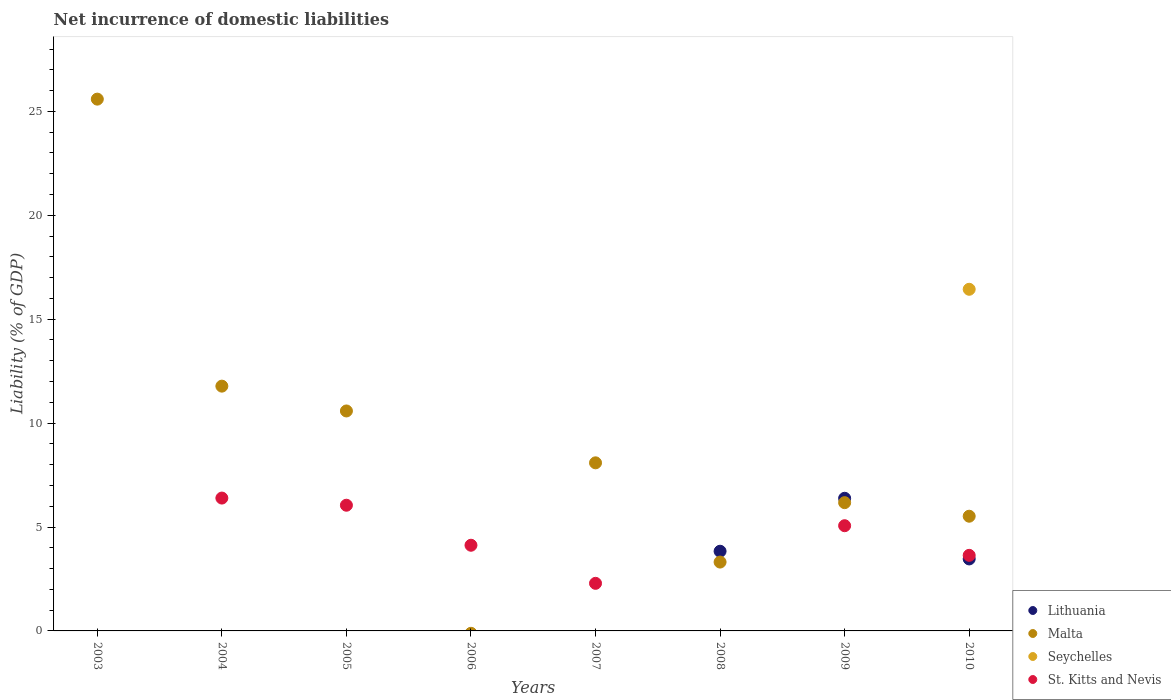What is the net incurrence of domestic liabilities in St. Kitts and Nevis in 2006?
Give a very brief answer. 4.12. Across all years, what is the maximum net incurrence of domestic liabilities in Seychelles?
Keep it short and to the point. 16.44. Across all years, what is the minimum net incurrence of domestic liabilities in Seychelles?
Offer a terse response. 0. In which year was the net incurrence of domestic liabilities in Lithuania maximum?
Your response must be concise. 2009. What is the total net incurrence of domestic liabilities in St. Kitts and Nevis in the graph?
Offer a terse response. 27.55. What is the difference between the net incurrence of domestic liabilities in St. Kitts and Nevis in 2004 and that in 2006?
Give a very brief answer. 2.27. What is the average net incurrence of domestic liabilities in St. Kitts and Nevis per year?
Offer a terse response. 3.44. In the year 2010, what is the difference between the net incurrence of domestic liabilities in Lithuania and net incurrence of domestic liabilities in St. Kitts and Nevis?
Make the answer very short. -0.17. What is the ratio of the net incurrence of domestic liabilities in Malta in 2004 to that in 2009?
Offer a very short reply. 1.91. Is the net incurrence of domestic liabilities in Malta in 2003 less than that in 2008?
Offer a terse response. No. What is the difference between the highest and the second highest net incurrence of domestic liabilities in Malta?
Give a very brief answer. 13.81. What is the difference between the highest and the lowest net incurrence of domestic liabilities in Seychelles?
Keep it short and to the point. 16.44. Is it the case that in every year, the sum of the net incurrence of domestic liabilities in St. Kitts and Nevis and net incurrence of domestic liabilities in Malta  is greater than the net incurrence of domestic liabilities in Seychelles?
Provide a short and direct response. No. Does the net incurrence of domestic liabilities in Lithuania monotonically increase over the years?
Offer a terse response. No. Is the net incurrence of domestic liabilities in Malta strictly less than the net incurrence of domestic liabilities in Lithuania over the years?
Offer a terse response. No. What is the difference between two consecutive major ticks on the Y-axis?
Ensure brevity in your answer.  5. Are the values on the major ticks of Y-axis written in scientific E-notation?
Provide a short and direct response. No. Does the graph contain any zero values?
Provide a short and direct response. Yes. Does the graph contain grids?
Ensure brevity in your answer.  No. Where does the legend appear in the graph?
Your answer should be very brief. Bottom right. How many legend labels are there?
Your answer should be compact. 4. How are the legend labels stacked?
Your answer should be very brief. Vertical. What is the title of the graph?
Keep it short and to the point. Net incurrence of domestic liabilities. Does "Costa Rica" appear as one of the legend labels in the graph?
Your answer should be very brief. No. What is the label or title of the X-axis?
Offer a very short reply. Years. What is the label or title of the Y-axis?
Provide a succinct answer. Liability (% of GDP). What is the Liability (% of GDP) in Lithuania in 2003?
Ensure brevity in your answer.  0. What is the Liability (% of GDP) of Malta in 2003?
Your response must be concise. 25.59. What is the Liability (% of GDP) of Seychelles in 2003?
Your answer should be very brief. 0. What is the Liability (% of GDP) in Malta in 2004?
Provide a short and direct response. 11.78. What is the Liability (% of GDP) of St. Kitts and Nevis in 2004?
Ensure brevity in your answer.  6.39. What is the Liability (% of GDP) in Malta in 2005?
Make the answer very short. 10.58. What is the Liability (% of GDP) in Seychelles in 2005?
Give a very brief answer. 0. What is the Liability (% of GDP) of St. Kitts and Nevis in 2005?
Your answer should be compact. 6.05. What is the Liability (% of GDP) of Seychelles in 2006?
Make the answer very short. 0. What is the Liability (% of GDP) in St. Kitts and Nevis in 2006?
Ensure brevity in your answer.  4.12. What is the Liability (% of GDP) in Malta in 2007?
Your response must be concise. 8.09. What is the Liability (% of GDP) of Seychelles in 2007?
Your answer should be very brief. 0. What is the Liability (% of GDP) of St. Kitts and Nevis in 2007?
Keep it short and to the point. 2.29. What is the Liability (% of GDP) of Lithuania in 2008?
Provide a short and direct response. 3.83. What is the Liability (% of GDP) of Malta in 2008?
Give a very brief answer. 3.31. What is the Liability (% of GDP) of Lithuania in 2009?
Your answer should be compact. 6.38. What is the Liability (% of GDP) in Malta in 2009?
Keep it short and to the point. 6.17. What is the Liability (% of GDP) of St. Kitts and Nevis in 2009?
Provide a short and direct response. 5.06. What is the Liability (% of GDP) of Lithuania in 2010?
Your answer should be very brief. 3.46. What is the Liability (% of GDP) of Malta in 2010?
Offer a very short reply. 5.52. What is the Liability (% of GDP) in Seychelles in 2010?
Provide a succinct answer. 16.44. What is the Liability (% of GDP) of St. Kitts and Nevis in 2010?
Your answer should be compact. 3.64. Across all years, what is the maximum Liability (% of GDP) of Lithuania?
Offer a terse response. 6.38. Across all years, what is the maximum Liability (% of GDP) in Malta?
Your response must be concise. 25.59. Across all years, what is the maximum Liability (% of GDP) in Seychelles?
Give a very brief answer. 16.44. Across all years, what is the maximum Liability (% of GDP) of St. Kitts and Nevis?
Make the answer very short. 6.39. Across all years, what is the minimum Liability (% of GDP) in Malta?
Provide a short and direct response. 0. Across all years, what is the minimum Liability (% of GDP) in Seychelles?
Give a very brief answer. 0. Across all years, what is the minimum Liability (% of GDP) of St. Kitts and Nevis?
Your response must be concise. 0. What is the total Liability (% of GDP) in Lithuania in the graph?
Your response must be concise. 13.68. What is the total Liability (% of GDP) in Malta in the graph?
Your answer should be very brief. 71.05. What is the total Liability (% of GDP) in Seychelles in the graph?
Offer a terse response. 16.44. What is the total Liability (% of GDP) of St. Kitts and Nevis in the graph?
Offer a very short reply. 27.55. What is the difference between the Liability (% of GDP) of Malta in 2003 and that in 2004?
Keep it short and to the point. 13.81. What is the difference between the Liability (% of GDP) of Malta in 2003 and that in 2005?
Give a very brief answer. 15.01. What is the difference between the Liability (% of GDP) in Malta in 2003 and that in 2007?
Give a very brief answer. 17.5. What is the difference between the Liability (% of GDP) in Malta in 2003 and that in 2008?
Make the answer very short. 22.28. What is the difference between the Liability (% of GDP) of Malta in 2003 and that in 2009?
Give a very brief answer. 19.42. What is the difference between the Liability (% of GDP) of Malta in 2003 and that in 2010?
Offer a very short reply. 20.07. What is the difference between the Liability (% of GDP) of Malta in 2004 and that in 2005?
Your response must be concise. 1.19. What is the difference between the Liability (% of GDP) in St. Kitts and Nevis in 2004 and that in 2005?
Provide a succinct answer. 0.34. What is the difference between the Liability (% of GDP) in St. Kitts and Nevis in 2004 and that in 2006?
Offer a terse response. 2.27. What is the difference between the Liability (% of GDP) in Malta in 2004 and that in 2007?
Make the answer very short. 3.69. What is the difference between the Liability (% of GDP) in St. Kitts and Nevis in 2004 and that in 2007?
Ensure brevity in your answer.  4.1. What is the difference between the Liability (% of GDP) of Malta in 2004 and that in 2008?
Give a very brief answer. 8.47. What is the difference between the Liability (% of GDP) in Malta in 2004 and that in 2009?
Give a very brief answer. 5.61. What is the difference between the Liability (% of GDP) in St. Kitts and Nevis in 2004 and that in 2009?
Keep it short and to the point. 1.33. What is the difference between the Liability (% of GDP) in Malta in 2004 and that in 2010?
Offer a very short reply. 6.26. What is the difference between the Liability (% of GDP) of St. Kitts and Nevis in 2004 and that in 2010?
Provide a short and direct response. 2.76. What is the difference between the Liability (% of GDP) in St. Kitts and Nevis in 2005 and that in 2006?
Offer a terse response. 1.93. What is the difference between the Liability (% of GDP) in Malta in 2005 and that in 2007?
Your answer should be very brief. 2.5. What is the difference between the Liability (% of GDP) in St. Kitts and Nevis in 2005 and that in 2007?
Make the answer very short. 3.76. What is the difference between the Liability (% of GDP) of Malta in 2005 and that in 2008?
Provide a short and direct response. 7.27. What is the difference between the Liability (% of GDP) in Malta in 2005 and that in 2009?
Provide a succinct answer. 4.41. What is the difference between the Liability (% of GDP) in St. Kitts and Nevis in 2005 and that in 2009?
Provide a short and direct response. 0.99. What is the difference between the Liability (% of GDP) of Malta in 2005 and that in 2010?
Provide a short and direct response. 5.06. What is the difference between the Liability (% of GDP) of St. Kitts and Nevis in 2005 and that in 2010?
Make the answer very short. 2.41. What is the difference between the Liability (% of GDP) in St. Kitts and Nevis in 2006 and that in 2007?
Make the answer very short. 1.83. What is the difference between the Liability (% of GDP) in St. Kitts and Nevis in 2006 and that in 2009?
Your answer should be compact. -0.94. What is the difference between the Liability (% of GDP) of St. Kitts and Nevis in 2006 and that in 2010?
Provide a short and direct response. 0.49. What is the difference between the Liability (% of GDP) in Malta in 2007 and that in 2008?
Give a very brief answer. 4.78. What is the difference between the Liability (% of GDP) in Malta in 2007 and that in 2009?
Provide a succinct answer. 1.92. What is the difference between the Liability (% of GDP) in St. Kitts and Nevis in 2007 and that in 2009?
Provide a succinct answer. -2.77. What is the difference between the Liability (% of GDP) of Malta in 2007 and that in 2010?
Provide a succinct answer. 2.57. What is the difference between the Liability (% of GDP) in St. Kitts and Nevis in 2007 and that in 2010?
Ensure brevity in your answer.  -1.35. What is the difference between the Liability (% of GDP) of Lithuania in 2008 and that in 2009?
Make the answer very short. -2.55. What is the difference between the Liability (% of GDP) of Malta in 2008 and that in 2009?
Offer a terse response. -2.86. What is the difference between the Liability (% of GDP) in Lithuania in 2008 and that in 2010?
Give a very brief answer. 0.37. What is the difference between the Liability (% of GDP) in Malta in 2008 and that in 2010?
Your answer should be compact. -2.21. What is the difference between the Liability (% of GDP) of Lithuania in 2009 and that in 2010?
Your answer should be very brief. 2.92. What is the difference between the Liability (% of GDP) in Malta in 2009 and that in 2010?
Your answer should be very brief. 0.65. What is the difference between the Liability (% of GDP) of St. Kitts and Nevis in 2009 and that in 2010?
Offer a terse response. 1.43. What is the difference between the Liability (% of GDP) in Malta in 2003 and the Liability (% of GDP) in St. Kitts and Nevis in 2004?
Your answer should be compact. 19.2. What is the difference between the Liability (% of GDP) of Malta in 2003 and the Liability (% of GDP) of St. Kitts and Nevis in 2005?
Offer a terse response. 19.54. What is the difference between the Liability (% of GDP) in Malta in 2003 and the Liability (% of GDP) in St. Kitts and Nevis in 2006?
Give a very brief answer. 21.47. What is the difference between the Liability (% of GDP) of Malta in 2003 and the Liability (% of GDP) of St. Kitts and Nevis in 2007?
Your answer should be compact. 23.3. What is the difference between the Liability (% of GDP) of Malta in 2003 and the Liability (% of GDP) of St. Kitts and Nevis in 2009?
Offer a terse response. 20.53. What is the difference between the Liability (% of GDP) of Malta in 2003 and the Liability (% of GDP) of Seychelles in 2010?
Make the answer very short. 9.15. What is the difference between the Liability (% of GDP) in Malta in 2003 and the Liability (% of GDP) in St. Kitts and Nevis in 2010?
Provide a succinct answer. 21.95. What is the difference between the Liability (% of GDP) of Malta in 2004 and the Liability (% of GDP) of St. Kitts and Nevis in 2005?
Provide a succinct answer. 5.73. What is the difference between the Liability (% of GDP) of Malta in 2004 and the Liability (% of GDP) of St. Kitts and Nevis in 2006?
Make the answer very short. 7.66. What is the difference between the Liability (% of GDP) in Malta in 2004 and the Liability (% of GDP) in St. Kitts and Nevis in 2007?
Give a very brief answer. 9.49. What is the difference between the Liability (% of GDP) of Malta in 2004 and the Liability (% of GDP) of St. Kitts and Nevis in 2009?
Your response must be concise. 6.72. What is the difference between the Liability (% of GDP) in Malta in 2004 and the Liability (% of GDP) in Seychelles in 2010?
Offer a terse response. -4.66. What is the difference between the Liability (% of GDP) in Malta in 2004 and the Liability (% of GDP) in St. Kitts and Nevis in 2010?
Offer a very short reply. 8.14. What is the difference between the Liability (% of GDP) of Malta in 2005 and the Liability (% of GDP) of St. Kitts and Nevis in 2006?
Make the answer very short. 6.46. What is the difference between the Liability (% of GDP) of Malta in 2005 and the Liability (% of GDP) of St. Kitts and Nevis in 2007?
Your answer should be compact. 8.29. What is the difference between the Liability (% of GDP) in Malta in 2005 and the Liability (% of GDP) in St. Kitts and Nevis in 2009?
Your answer should be compact. 5.52. What is the difference between the Liability (% of GDP) of Malta in 2005 and the Liability (% of GDP) of Seychelles in 2010?
Provide a succinct answer. -5.86. What is the difference between the Liability (% of GDP) of Malta in 2005 and the Liability (% of GDP) of St. Kitts and Nevis in 2010?
Give a very brief answer. 6.95. What is the difference between the Liability (% of GDP) of Malta in 2007 and the Liability (% of GDP) of St. Kitts and Nevis in 2009?
Your answer should be very brief. 3.03. What is the difference between the Liability (% of GDP) in Malta in 2007 and the Liability (% of GDP) in Seychelles in 2010?
Ensure brevity in your answer.  -8.35. What is the difference between the Liability (% of GDP) in Malta in 2007 and the Liability (% of GDP) in St. Kitts and Nevis in 2010?
Your answer should be compact. 4.45. What is the difference between the Liability (% of GDP) of Lithuania in 2008 and the Liability (% of GDP) of Malta in 2009?
Offer a terse response. -2.34. What is the difference between the Liability (% of GDP) in Lithuania in 2008 and the Liability (% of GDP) in St. Kitts and Nevis in 2009?
Make the answer very short. -1.23. What is the difference between the Liability (% of GDP) of Malta in 2008 and the Liability (% of GDP) of St. Kitts and Nevis in 2009?
Your answer should be very brief. -1.75. What is the difference between the Liability (% of GDP) of Lithuania in 2008 and the Liability (% of GDP) of Malta in 2010?
Keep it short and to the point. -1.69. What is the difference between the Liability (% of GDP) of Lithuania in 2008 and the Liability (% of GDP) of Seychelles in 2010?
Your answer should be very brief. -12.61. What is the difference between the Liability (% of GDP) in Lithuania in 2008 and the Liability (% of GDP) in St. Kitts and Nevis in 2010?
Keep it short and to the point. 0.2. What is the difference between the Liability (% of GDP) of Malta in 2008 and the Liability (% of GDP) of Seychelles in 2010?
Ensure brevity in your answer.  -13.13. What is the difference between the Liability (% of GDP) in Malta in 2008 and the Liability (% of GDP) in St. Kitts and Nevis in 2010?
Your answer should be very brief. -0.32. What is the difference between the Liability (% of GDP) of Lithuania in 2009 and the Liability (% of GDP) of Malta in 2010?
Offer a very short reply. 0.86. What is the difference between the Liability (% of GDP) of Lithuania in 2009 and the Liability (% of GDP) of Seychelles in 2010?
Your answer should be very brief. -10.06. What is the difference between the Liability (% of GDP) in Lithuania in 2009 and the Liability (% of GDP) in St. Kitts and Nevis in 2010?
Your answer should be very brief. 2.75. What is the difference between the Liability (% of GDP) in Malta in 2009 and the Liability (% of GDP) in Seychelles in 2010?
Make the answer very short. -10.27. What is the difference between the Liability (% of GDP) in Malta in 2009 and the Liability (% of GDP) in St. Kitts and Nevis in 2010?
Offer a very short reply. 2.54. What is the average Liability (% of GDP) in Lithuania per year?
Keep it short and to the point. 1.71. What is the average Liability (% of GDP) of Malta per year?
Provide a short and direct response. 8.88. What is the average Liability (% of GDP) in Seychelles per year?
Give a very brief answer. 2.05. What is the average Liability (% of GDP) in St. Kitts and Nevis per year?
Give a very brief answer. 3.44. In the year 2004, what is the difference between the Liability (% of GDP) in Malta and Liability (% of GDP) in St. Kitts and Nevis?
Offer a very short reply. 5.39. In the year 2005, what is the difference between the Liability (% of GDP) in Malta and Liability (% of GDP) in St. Kitts and Nevis?
Your answer should be compact. 4.54. In the year 2007, what is the difference between the Liability (% of GDP) of Malta and Liability (% of GDP) of St. Kitts and Nevis?
Offer a very short reply. 5.8. In the year 2008, what is the difference between the Liability (% of GDP) in Lithuania and Liability (% of GDP) in Malta?
Provide a succinct answer. 0.52. In the year 2009, what is the difference between the Liability (% of GDP) in Lithuania and Liability (% of GDP) in Malta?
Offer a terse response. 0.21. In the year 2009, what is the difference between the Liability (% of GDP) of Lithuania and Liability (% of GDP) of St. Kitts and Nevis?
Provide a succinct answer. 1.32. In the year 2009, what is the difference between the Liability (% of GDP) in Malta and Liability (% of GDP) in St. Kitts and Nevis?
Your answer should be compact. 1.11. In the year 2010, what is the difference between the Liability (% of GDP) in Lithuania and Liability (% of GDP) in Malta?
Offer a very short reply. -2.06. In the year 2010, what is the difference between the Liability (% of GDP) in Lithuania and Liability (% of GDP) in Seychelles?
Keep it short and to the point. -12.98. In the year 2010, what is the difference between the Liability (% of GDP) of Lithuania and Liability (% of GDP) of St. Kitts and Nevis?
Provide a succinct answer. -0.17. In the year 2010, what is the difference between the Liability (% of GDP) in Malta and Liability (% of GDP) in Seychelles?
Your answer should be very brief. -10.92. In the year 2010, what is the difference between the Liability (% of GDP) in Malta and Liability (% of GDP) in St. Kitts and Nevis?
Offer a very short reply. 1.88. In the year 2010, what is the difference between the Liability (% of GDP) of Seychelles and Liability (% of GDP) of St. Kitts and Nevis?
Make the answer very short. 12.8. What is the ratio of the Liability (% of GDP) in Malta in 2003 to that in 2004?
Your answer should be compact. 2.17. What is the ratio of the Liability (% of GDP) in Malta in 2003 to that in 2005?
Your answer should be very brief. 2.42. What is the ratio of the Liability (% of GDP) in Malta in 2003 to that in 2007?
Provide a short and direct response. 3.16. What is the ratio of the Liability (% of GDP) in Malta in 2003 to that in 2008?
Give a very brief answer. 7.72. What is the ratio of the Liability (% of GDP) of Malta in 2003 to that in 2009?
Your answer should be compact. 4.15. What is the ratio of the Liability (% of GDP) in Malta in 2003 to that in 2010?
Keep it short and to the point. 4.64. What is the ratio of the Liability (% of GDP) of Malta in 2004 to that in 2005?
Your answer should be very brief. 1.11. What is the ratio of the Liability (% of GDP) of St. Kitts and Nevis in 2004 to that in 2005?
Provide a succinct answer. 1.06. What is the ratio of the Liability (% of GDP) in St. Kitts and Nevis in 2004 to that in 2006?
Your answer should be compact. 1.55. What is the ratio of the Liability (% of GDP) in Malta in 2004 to that in 2007?
Your answer should be compact. 1.46. What is the ratio of the Liability (% of GDP) in St. Kitts and Nevis in 2004 to that in 2007?
Offer a very short reply. 2.79. What is the ratio of the Liability (% of GDP) of Malta in 2004 to that in 2008?
Provide a short and direct response. 3.56. What is the ratio of the Liability (% of GDP) in Malta in 2004 to that in 2009?
Offer a very short reply. 1.91. What is the ratio of the Liability (% of GDP) of St. Kitts and Nevis in 2004 to that in 2009?
Offer a terse response. 1.26. What is the ratio of the Liability (% of GDP) of Malta in 2004 to that in 2010?
Keep it short and to the point. 2.13. What is the ratio of the Liability (% of GDP) in St. Kitts and Nevis in 2004 to that in 2010?
Your answer should be very brief. 1.76. What is the ratio of the Liability (% of GDP) in St. Kitts and Nevis in 2005 to that in 2006?
Offer a very short reply. 1.47. What is the ratio of the Liability (% of GDP) of Malta in 2005 to that in 2007?
Your answer should be very brief. 1.31. What is the ratio of the Liability (% of GDP) of St. Kitts and Nevis in 2005 to that in 2007?
Your response must be concise. 2.64. What is the ratio of the Liability (% of GDP) of Malta in 2005 to that in 2008?
Your answer should be compact. 3.19. What is the ratio of the Liability (% of GDP) of Malta in 2005 to that in 2009?
Keep it short and to the point. 1.71. What is the ratio of the Liability (% of GDP) of St. Kitts and Nevis in 2005 to that in 2009?
Ensure brevity in your answer.  1.19. What is the ratio of the Liability (% of GDP) in Malta in 2005 to that in 2010?
Ensure brevity in your answer.  1.92. What is the ratio of the Liability (% of GDP) in St. Kitts and Nevis in 2005 to that in 2010?
Your answer should be compact. 1.66. What is the ratio of the Liability (% of GDP) of St. Kitts and Nevis in 2006 to that in 2007?
Keep it short and to the point. 1.8. What is the ratio of the Liability (% of GDP) of St. Kitts and Nevis in 2006 to that in 2009?
Provide a succinct answer. 0.81. What is the ratio of the Liability (% of GDP) in St. Kitts and Nevis in 2006 to that in 2010?
Provide a succinct answer. 1.13. What is the ratio of the Liability (% of GDP) of Malta in 2007 to that in 2008?
Offer a terse response. 2.44. What is the ratio of the Liability (% of GDP) of Malta in 2007 to that in 2009?
Make the answer very short. 1.31. What is the ratio of the Liability (% of GDP) in St. Kitts and Nevis in 2007 to that in 2009?
Ensure brevity in your answer.  0.45. What is the ratio of the Liability (% of GDP) of Malta in 2007 to that in 2010?
Provide a succinct answer. 1.47. What is the ratio of the Liability (% of GDP) of St. Kitts and Nevis in 2007 to that in 2010?
Ensure brevity in your answer.  0.63. What is the ratio of the Liability (% of GDP) in Lithuania in 2008 to that in 2009?
Your response must be concise. 0.6. What is the ratio of the Liability (% of GDP) of Malta in 2008 to that in 2009?
Your answer should be very brief. 0.54. What is the ratio of the Liability (% of GDP) of Lithuania in 2008 to that in 2010?
Offer a very short reply. 1.11. What is the ratio of the Liability (% of GDP) in Malta in 2008 to that in 2010?
Keep it short and to the point. 0.6. What is the ratio of the Liability (% of GDP) of Lithuania in 2009 to that in 2010?
Provide a short and direct response. 1.84. What is the ratio of the Liability (% of GDP) in Malta in 2009 to that in 2010?
Offer a terse response. 1.12. What is the ratio of the Liability (% of GDP) of St. Kitts and Nevis in 2009 to that in 2010?
Provide a short and direct response. 1.39. What is the difference between the highest and the second highest Liability (% of GDP) in Lithuania?
Your response must be concise. 2.55. What is the difference between the highest and the second highest Liability (% of GDP) in Malta?
Your answer should be very brief. 13.81. What is the difference between the highest and the second highest Liability (% of GDP) in St. Kitts and Nevis?
Your answer should be very brief. 0.34. What is the difference between the highest and the lowest Liability (% of GDP) of Lithuania?
Your response must be concise. 6.38. What is the difference between the highest and the lowest Liability (% of GDP) in Malta?
Provide a succinct answer. 25.59. What is the difference between the highest and the lowest Liability (% of GDP) of Seychelles?
Ensure brevity in your answer.  16.44. What is the difference between the highest and the lowest Liability (% of GDP) of St. Kitts and Nevis?
Your answer should be very brief. 6.39. 